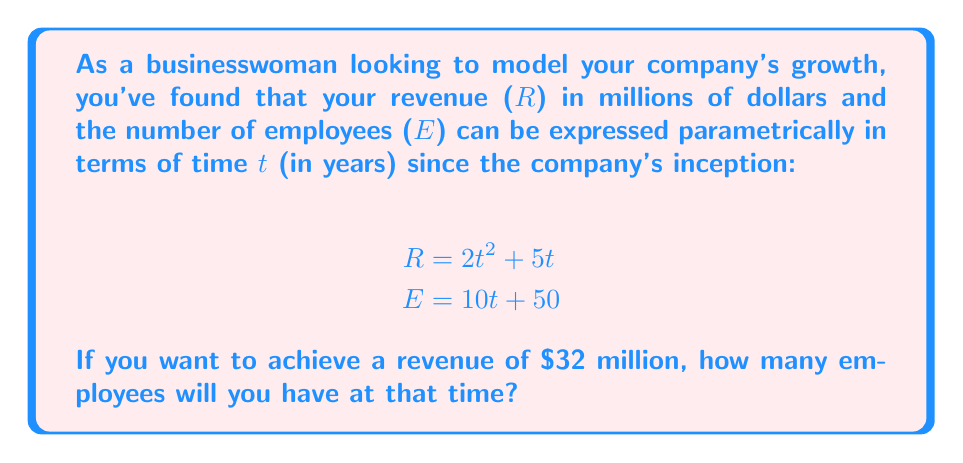Could you help me with this problem? To solve this problem, we need to follow these steps:

1. Find the time t when revenue reaches $32 million:
   $$32 = 2t^2 + 5t$$
   $$0 = 2t^2 + 5t - 32$$
   
   This is a quadratic equation. We can solve it using the quadratic formula:
   $$t = \frac{-b \pm \sqrt{b^2 - 4ac}}{2a}$$
   
   Where $a=2$, $b=5$, and $c=-32$

   $$t = \frac{-5 \pm \sqrt{5^2 - 4(2)(-32)}}{2(2)}$$
   $$t = \frac{-5 \pm \sqrt{25 + 256}}{4}$$
   $$t = \frac{-5 \pm \sqrt{281}}{4}$$

   This gives us two solutions:
   $$t_1 = \frac{-5 + \sqrt{281}}{4} \approx 3.68$$
   $$t_2 = \frac{-5 - \sqrt{281}}{4} \approx -4.68$$

   Since time cannot be negative in this context, we use $t \approx 3.68$ years.

2. Now that we know the time, we can substitute this value into the equation for the number of employees:

   $$E = 10t + 50$$
   $$E = 10(3.68) + 50$$
   $$E = 36.8 + 50$$
   $$E = 86.8$$

3. Since we can't have a fractional number of employees, we round up to the nearest whole number.
Answer: The company will have 87 employees when it reaches a revenue of $32 million. 